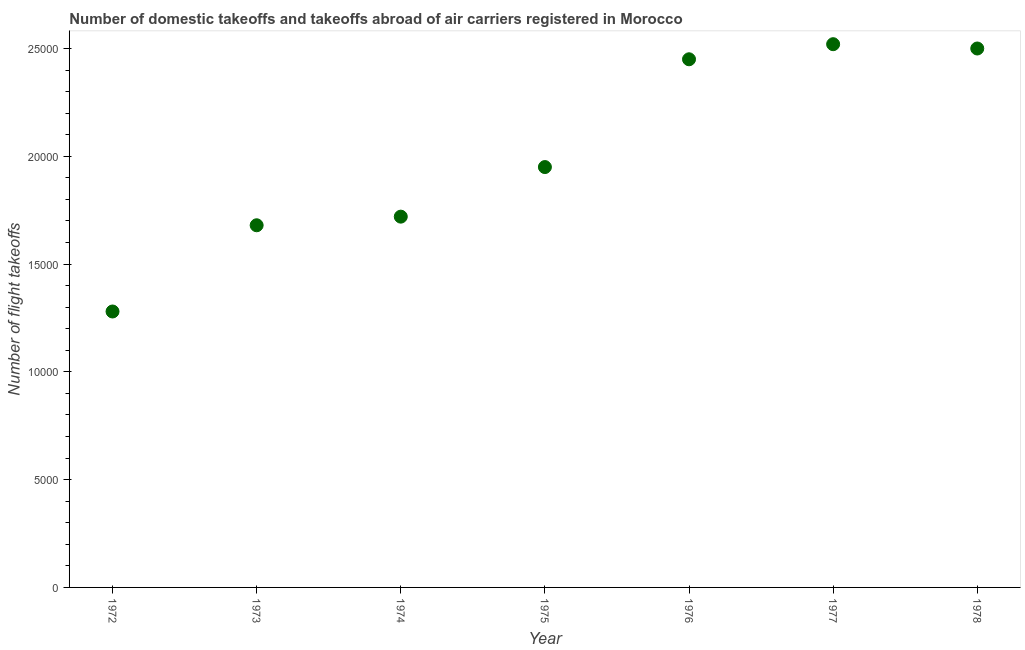What is the number of flight takeoffs in 1974?
Offer a very short reply. 1.72e+04. Across all years, what is the maximum number of flight takeoffs?
Offer a very short reply. 2.52e+04. Across all years, what is the minimum number of flight takeoffs?
Offer a very short reply. 1.28e+04. In which year was the number of flight takeoffs minimum?
Provide a succinct answer. 1972. What is the sum of the number of flight takeoffs?
Ensure brevity in your answer.  1.41e+05. What is the difference between the number of flight takeoffs in 1975 and 1976?
Your answer should be very brief. -5000. What is the average number of flight takeoffs per year?
Give a very brief answer. 2.01e+04. What is the median number of flight takeoffs?
Your response must be concise. 1.95e+04. Do a majority of the years between 1978 and 1974 (inclusive) have number of flight takeoffs greater than 18000 ?
Ensure brevity in your answer.  Yes. What is the ratio of the number of flight takeoffs in 1976 to that in 1977?
Make the answer very short. 0.97. Is the difference between the number of flight takeoffs in 1975 and 1976 greater than the difference between any two years?
Give a very brief answer. No. What is the difference between the highest and the second highest number of flight takeoffs?
Your response must be concise. 200. What is the difference between the highest and the lowest number of flight takeoffs?
Provide a succinct answer. 1.24e+04. In how many years, is the number of flight takeoffs greater than the average number of flight takeoffs taken over all years?
Make the answer very short. 3. How many dotlines are there?
Provide a succinct answer. 1. How many years are there in the graph?
Offer a terse response. 7. Are the values on the major ticks of Y-axis written in scientific E-notation?
Provide a succinct answer. No. Does the graph contain any zero values?
Your answer should be very brief. No. Does the graph contain grids?
Offer a terse response. No. What is the title of the graph?
Offer a terse response. Number of domestic takeoffs and takeoffs abroad of air carriers registered in Morocco. What is the label or title of the Y-axis?
Keep it short and to the point. Number of flight takeoffs. What is the Number of flight takeoffs in 1972?
Ensure brevity in your answer.  1.28e+04. What is the Number of flight takeoffs in 1973?
Offer a very short reply. 1.68e+04. What is the Number of flight takeoffs in 1974?
Provide a succinct answer. 1.72e+04. What is the Number of flight takeoffs in 1975?
Give a very brief answer. 1.95e+04. What is the Number of flight takeoffs in 1976?
Offer a very short reply. 2.45e+04. What is the Number of flight takeoffs in 1977?
Give a very brief answer. 2.52e+04. What is the Number of flight takeoffs in 1978?
Offer a very short reply. 2.50e+04. What is the difference between the Number of flight takeoffs in 1972 and 1973?
Your answer should be very brief. -4000. What is the difference between the Number of flight takeoffs in 1972 and 1974?
Give a very brief answer. -4400. What is the difference between the Number of flight takeoffs in 1972 and 1975?
Ensure brevity in your answer.  -6700. What is the difference between the Number of flight takeoffs in 1972 and 1976?
Keep it short and to the point. -1.17e+04. What is the difference between the Number of flight takeoffs in 1972 and 1977?
Your answer should be very brief. -1.24e+04. What is the difference between the Number of flight takeoffs in 1972 and 1978?
Provide a succinct answer. -1.22e+04. What is the difference between the Number of flight takeoffs in 1973 and 1974?
Ensure brevity in your answer.  -400. What is the difference between the Number of flight takeoffs in 1973 and 1975?
Ensure brevity in your answer.  -2700. What is the difference between the Number of flight takeoffs in 1973 and 1976?
Offer a terse response. -7700. What is the difference between the Number of flight takeoffs in 1973 and 1977?
Keep it short and to the point. -8400. What is the difference between the Number of flight takeoffs in 1973 and 1978?
Give a very brief answer. -8200. What is the difference between the Number of flight takeoffs in 1974 and 1975?
Your answer should be compact. -2300. What is the difference between the Number of flight takeoffs in 1974 and 1976?
Keep it short and to the point. -7300. What is the difference between the Number of flight takeoffs in 1974 and 1977?
Ensure brevity in your answer.  -8000. What is the difference between the Number of flight takeoffs in 1974 and 1978?
Ensure brevity in your answer.  -7800. What is the difference between the Number of flight takeoffs in 1975 and 1976?
Keep it short and to the point. -5000. What is the difference between the Number of flight takeoffs in 1975 and 1977?
Your answer should be very brief. -5700. What is the difference between the Number of flight takeoffs in 1975 and 1978?
Your answer should be compact. -5500. What is the difference between the Number of flight takeoffs in 1976 and 1977?
Provide a short and direct response. -700. What is the difference between the Number of flight takeoffs in 1976 and 1978?
Give a very brief answer. -500. What is the difference between the Number of flight takeoffs in 1977 and 1978?
Your answer should be very brief. 200. What is the ratio of the Number of flight takeoffs in 1972 to that in 1973?
Provide a short and direct response. 0.76. What is the ratio of the Number of flight takeoffs in 1972 to that in 1974?
Your answer should be very brief. 0.74. What is the ratio of the Number of flight takeoffs in 1972 to that in 1975?
Give a very brief answer. 0.66. What is the ratio of the Number of flight takeoffs in 1972 to that in 1976?
Offer a very short reply. 0.52. What is the ratio of the Number of flight takeoffs in 1972 to that in 1977?
Offer a very short reply. 0.51. What is the ratio of the Number of flight takeoffs in 1972 to that in 1978?
Ensure brevity in your answer.  0.51. What is the ratio of the Number of flight takeoffs in 1973 to that in 1974?
Provide a succinct answer. 0.98. What is the ratio of the Number of flight takeoffs in 1973 to that in 1975?
Give a very brief answer. 0.86. What is the ratio of the Number of flight takeoffs in 1973 to that in 1976?
Give a very brief answer. 0.69. What is the ratio of the Number of flight takeoffs in 1973 to that in 1977?
Offer a terse response. 0.67. What is the ratio of the Number of flight takeoffs in 1973 to that in 1978?
Give a very brief answer. 0.67. What is the ratio of the Number of flight takeoffs in 1974 to that in 1975?
Ensure brevity in your answer.  0.88. What is the ratio of the Number of flight takeoffs in 1974 to that in 1976?
Your answer should be compact. 0.7. What is the ratio of the Number of flight takeoffs in 1974 to that in 1977?
Your answer should be compact. 0.68. What is the ratio of the Number of flight takeoffs in 1974 to that in 1978?
Ensure brevity in your answer.  0.69. What is the ratio of the Number of flight takeoffs in 1975 to that in 1976?
Offer a terse response. 0.8. What is the ratio of the Number of flight takeoffs in 1975 to that in 1977?
Keep it short and to the point. 0.77. What is the ratio of the Number of flight takeoffs in 1975 to that in 1978?
Offer a very short reply. 0.78. What is the ratio of the Number of flight takeoffs in 1976 to that in 1977?
Offer a terse response. 0.97. What is the ratio of the Number of flight takeoffs in 1977 to that in 1978?
Make the answer very short. 1.01. 